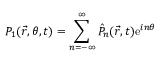Convert formula to latex. <formula><loc_0><loc_0><loc_500><loc_500>P _ { 1 } ( \vec { r } , \theta , t ) = \sum _ { n = - \infty } ^ { \infty } \hat { P } _ { n } ( \vec { r } , t ) e ^ { i n \theta }</formula> 